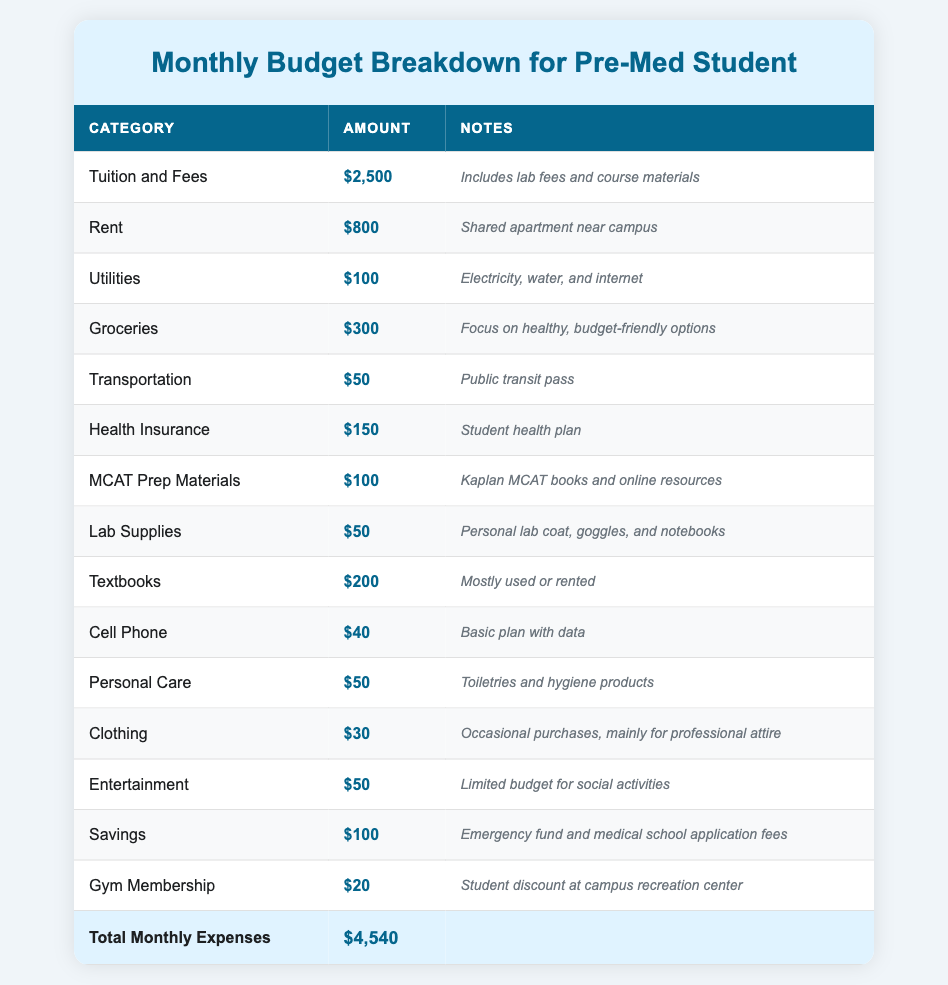What is the total amount allocated for tuition and fees? The row for "Tuition and Fees" shows an amount of $2,500.
Answer: $2,500 How much is spent on groceries each month? The "Groceries" category in the table indicates an amount of $300.
Answer: $300 Is the rent more than the total spent on entertainment? Rent is $800 and entertainment is $50, so $800 is greater than $50, which means the statement is true.
Answer: Yes What is the combined total of health insurance and transportation costs? The health insurance is $150 and transportation is $50. Adding these amounts gives $150 + $50 = $200.
Answer: $200 What percentage of the total monthly expenses is allocated to rent? The total monthly expenses sum up to $4,540. To find the percentage for rent, divide the rent amount ($800) by the total expenses ($4,540) and multiply by 100: ($800 / $4,540) * 100 ≈ 17.6%.
Answer: 17.6% What is the total amount for personal care, clothing, and gym membership? Personal care is $50, clothing is $30, and gym membership is $20. Adding these gives $50 + $30 + $20 = $100.
Answer: $100 Are the monthly expenses for MCAT prep materials greater than the total spent on lab supplies and textbooks combined? MCAT prep materials are $100, lab supplies are $50, and textbooks are $200. The combined amount for lab supplies and textbooks is $50 + $200 = $250, which is greater than $100, meaning the statement is false.
Answer: No What is the total monthly budget for utilities and personal care? Utilities cost $100 and personal care costs $50. Adding these amounts gives $100 + $50 = $150.
Answer: $150 How much savings does the pre-med student allocate each month? The savings category shows an amount of $100 per month.
Answer: $100 What is the total amount spent on textbooks and MCAT prep materials together? Textbooks cost $200 and MCAT prep materials cost $100. Adding these amounts gives $200 + $100 = $300.
Answer: $300 